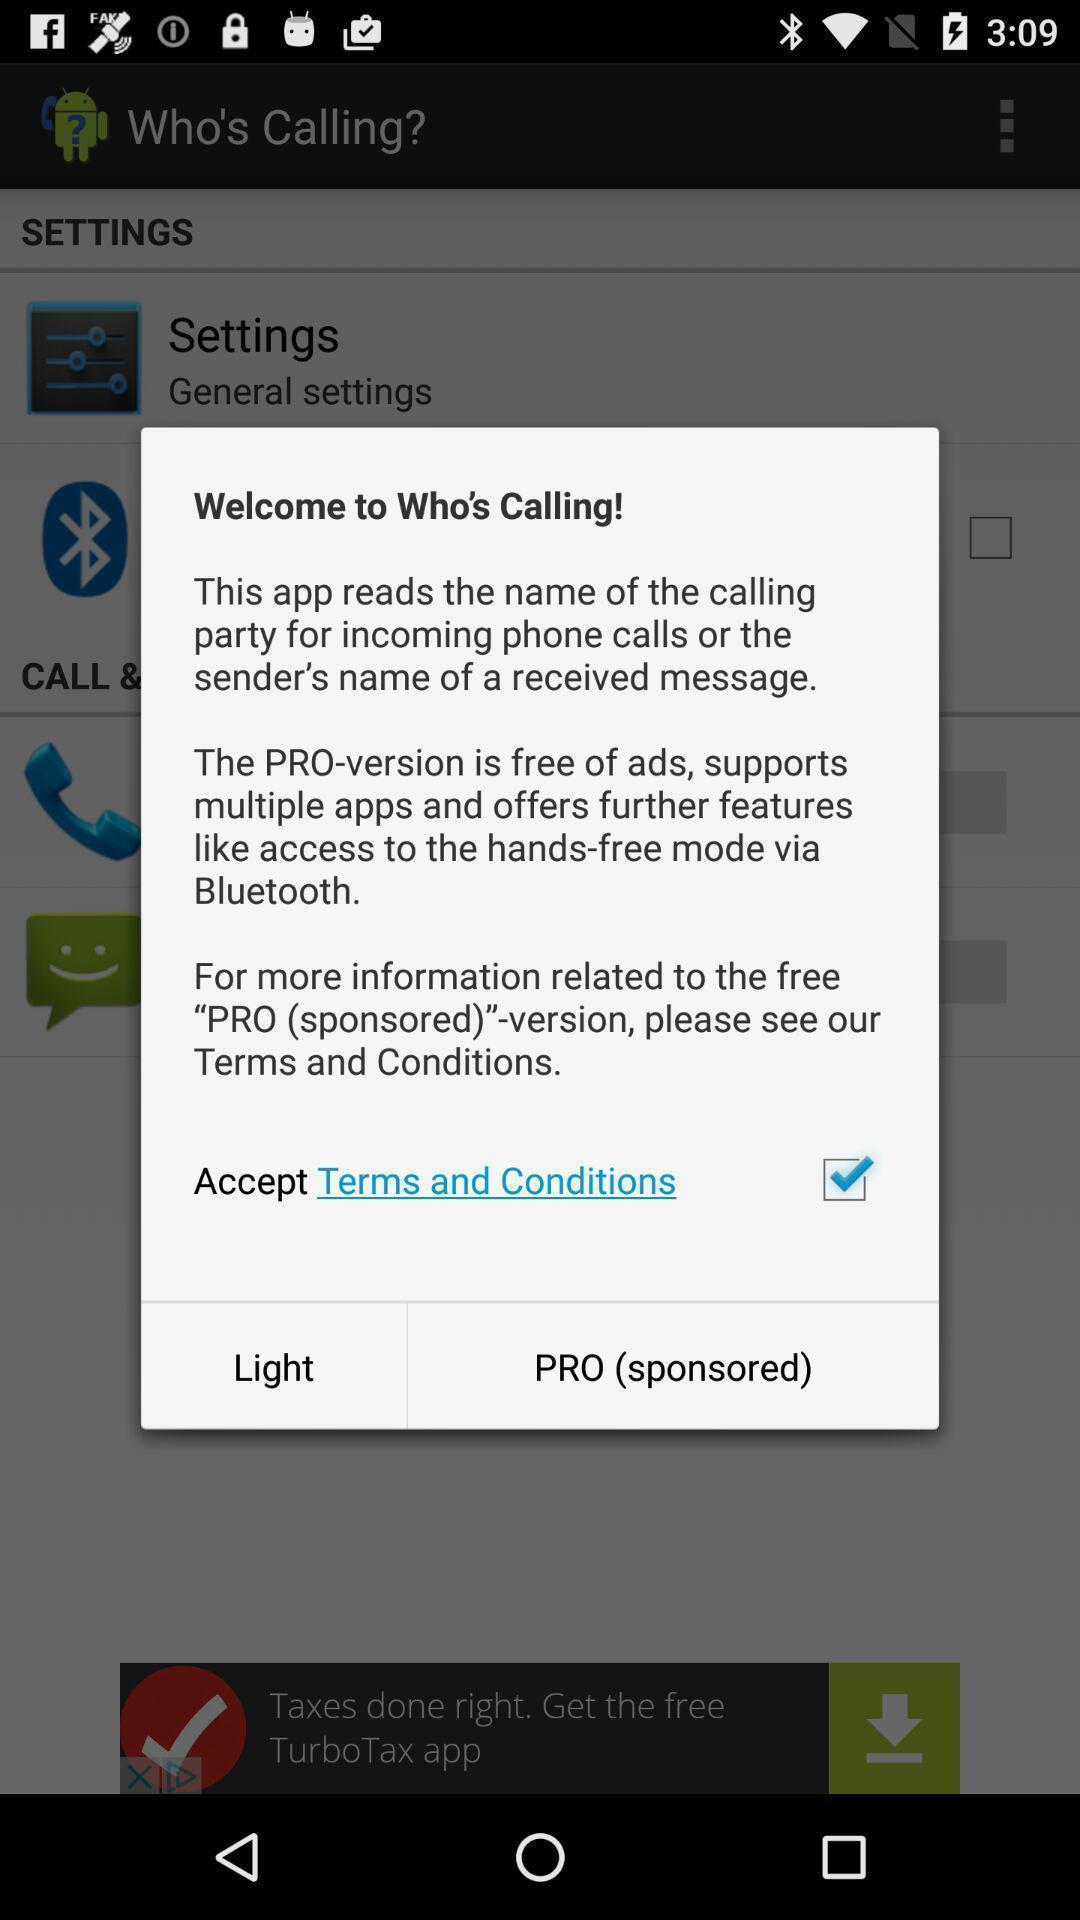What can you discern from this picture? Pop-up showing welcome page for an app. 